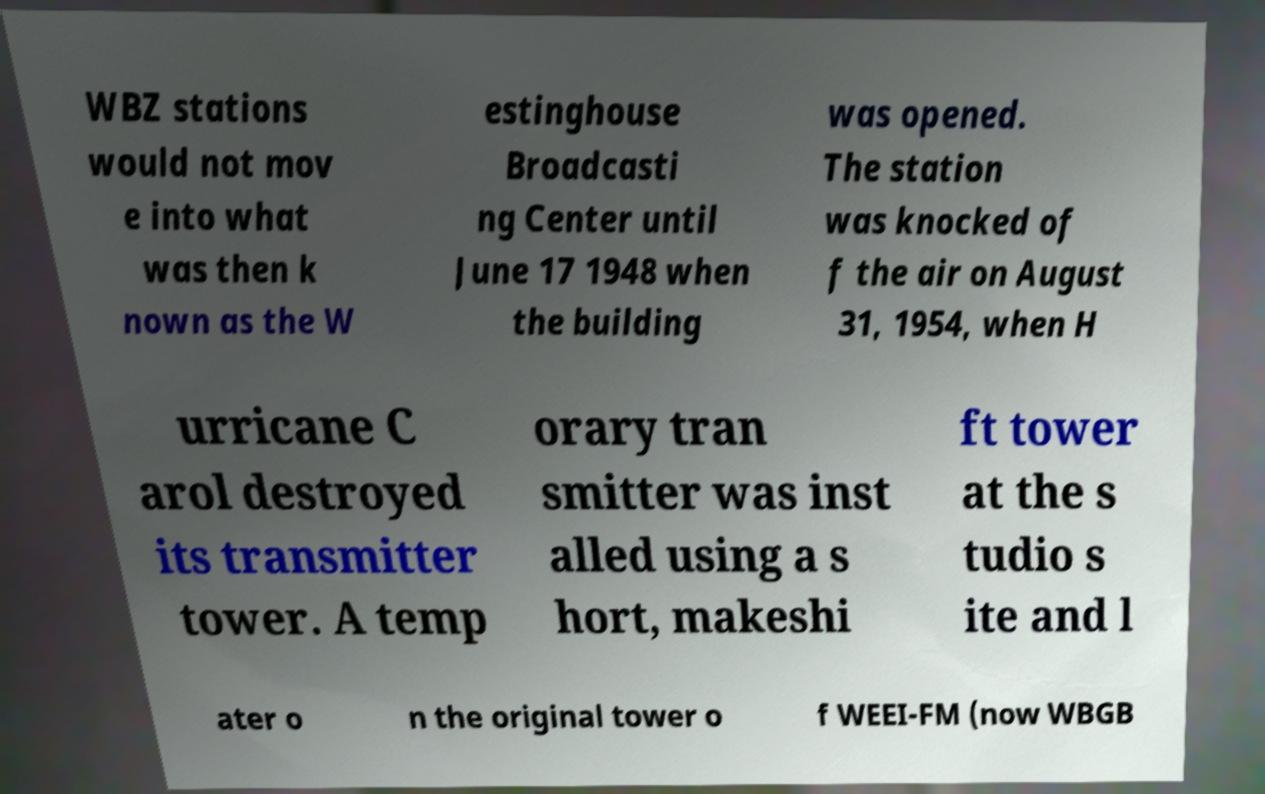I need the written content from this picture converted into text. Can you do that? WBZ stations would not mov e into what was then k nown as the W estinghouse Broadcasti ng Center until June 17 1948 when the building was opened. The station was knocked of f the air on August 31, 1954, when H urricane C arol destroyed its transmitter tower. A temp orary tran smitter was inst alled using a s hort, makeshi ft tower at the s tudio s ite and l ater o n the original tower o f WEEI-FM (now WBGB 